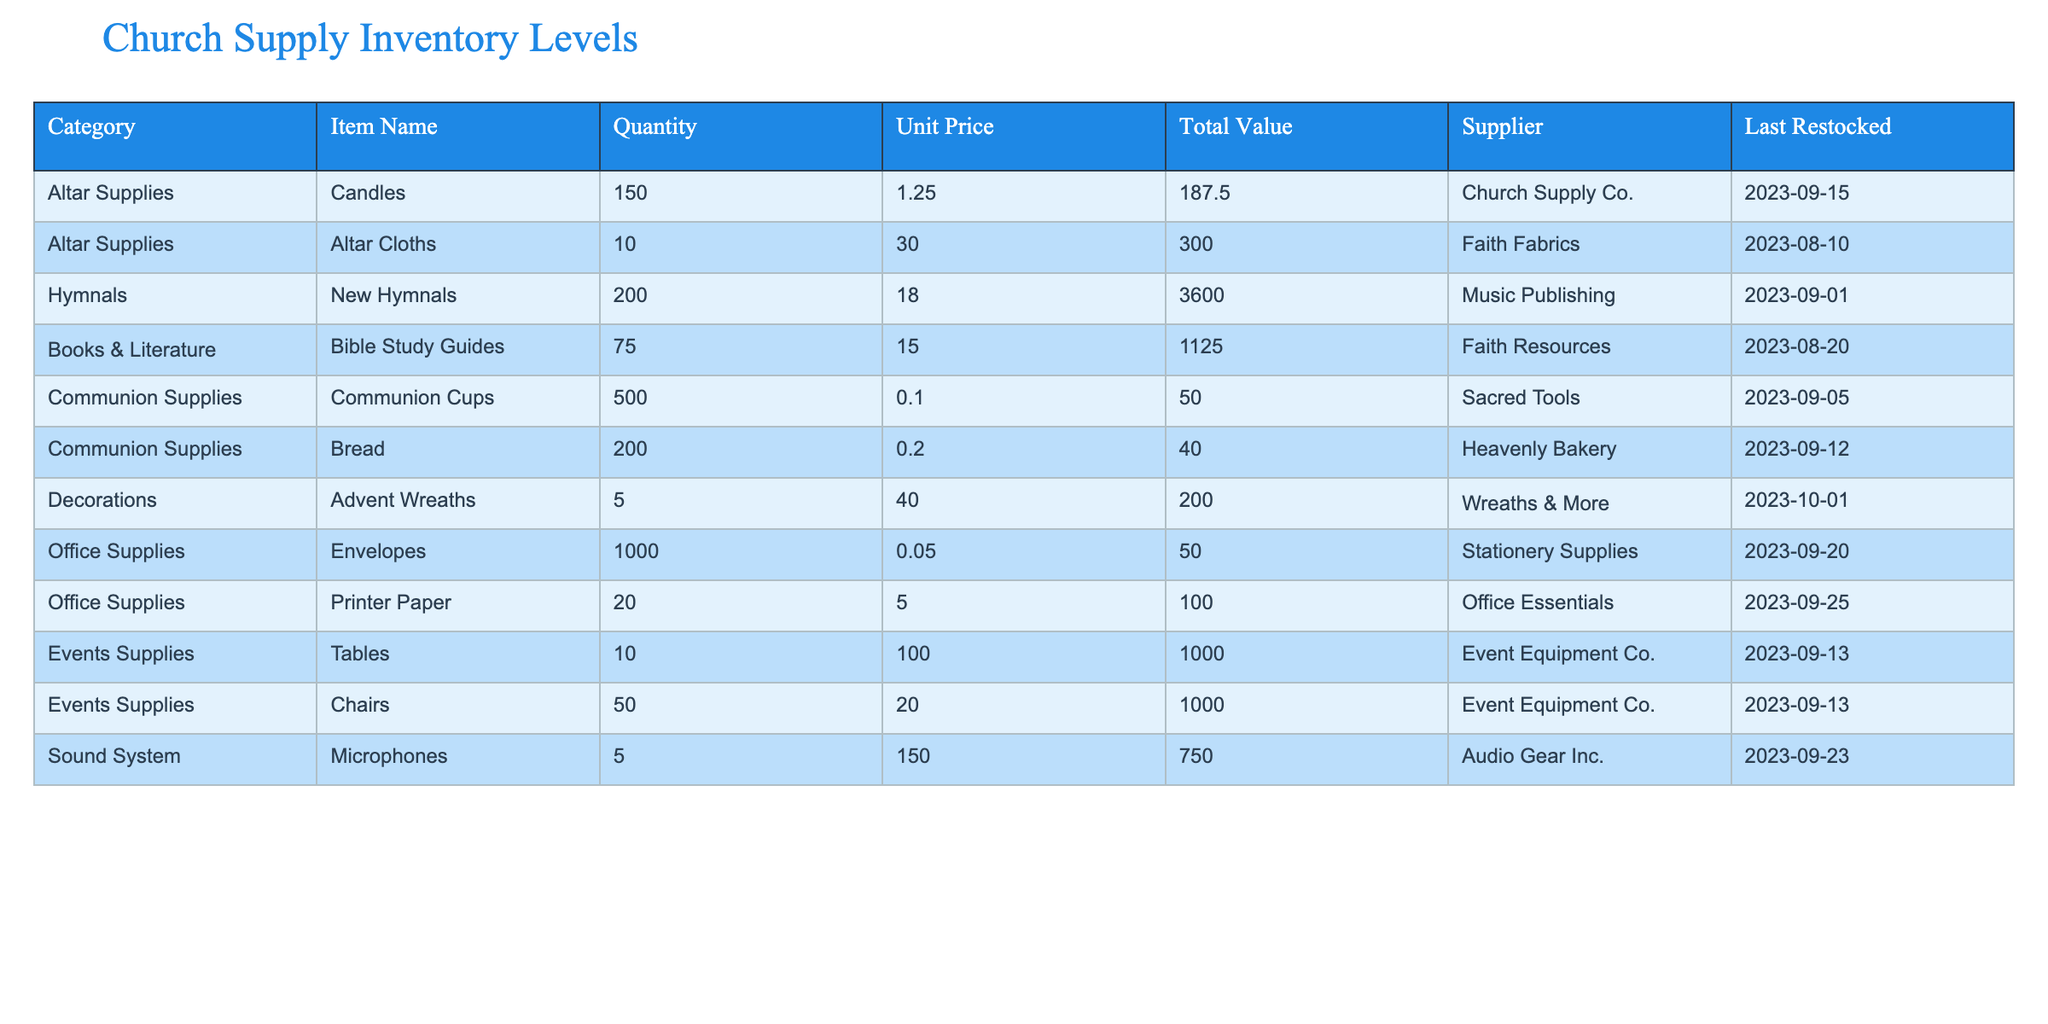What is the total quantity of Altar Supplies? From the table, the Altar Supplies consist of two items: Candles with a quantity of 150 and Altar Cloths with a quantity of 10. Adding these quantities together, 150 + 10, gives us a total of 160.
Answer: 160 Which supplier provides the most expensive item and what is the item? The table shows the item "Altar Cloths" with a unit price of 30.00 from Faith Fabrics, which is the highest unit price of all items listed. After reviewing all items, no other supplier has an item priced higher than that.
Answer: Altar Cloths, Faith Fabrics How many Communion Supplies are there in total? The total count of Communion Supplies includes Communion Cups (500) and Bread (200). Adding these together, 500 + 200 results in 700.
Answer: 700 Is the last restock date for Envelopes earlier than that for Microphones? The last restock date for Envelopes is 2023-09-20, while for Microphones it is 2023-09-23. Since 2023-09-20 is earlier than 2023-09-23, the statement is true.
Answer: Yes What is the total value of Office Supplies? From the table, the total value of Office Supplies is calculated by adding the individual values. Printer Paper is 100.00 and Envelopes is 50.00, so, 100.00 + 50.00 = 150.00.
Answer: 150.00 How many items are listed under Events Supplies, and what is their combined total value? The table shows two items in Events Supplies: Tables and Chairs. Tables have a total value of 1000.00, and Chairs also have a total value of 1000.00. Therefore, the total value for Events Supplies is 1000.00 + 1000.00 = 2000.00.
Answer: 2000.00 Are there more non-liturgical items (like Decorations) than liturgical items (like Communion Supplies) in inventory? Counting the non-liturgical items: Decorations (1), Office Supplies (2), Events Supplies (2), and Sound System (1) gives us a total of 6. Counting the liturgical items: Altar Supplies (2) and Communion Supplies (2) gives us 4. Since 6 (non-liturgical) is greater than 4 (liturgical), the statement is true.
Answer: Yes What item in the Decorations category was last restocked most recently? The only item listed under Decorations is Advent Wreaths, which was last restocked on 2023-10-01, making it the most recently restocked item in this category.
Answer: Advent Wreaths 